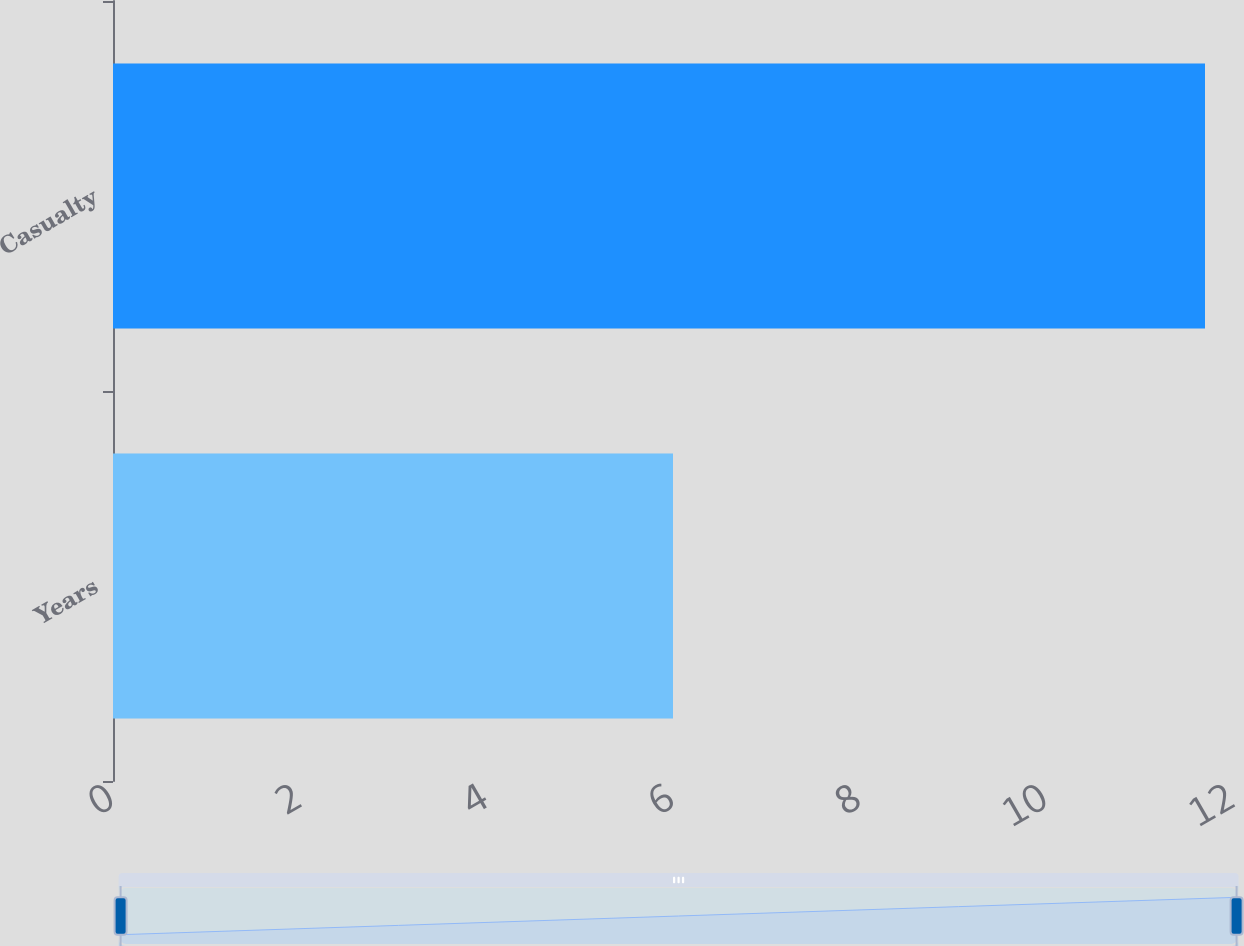Convert chart. <chart><loc_0><loc_0><loc_500><loc_500><bar_chart><fcel>Years<fcel>Casualty<nl><fcel>6<fcel>11.7<nl></chart> 